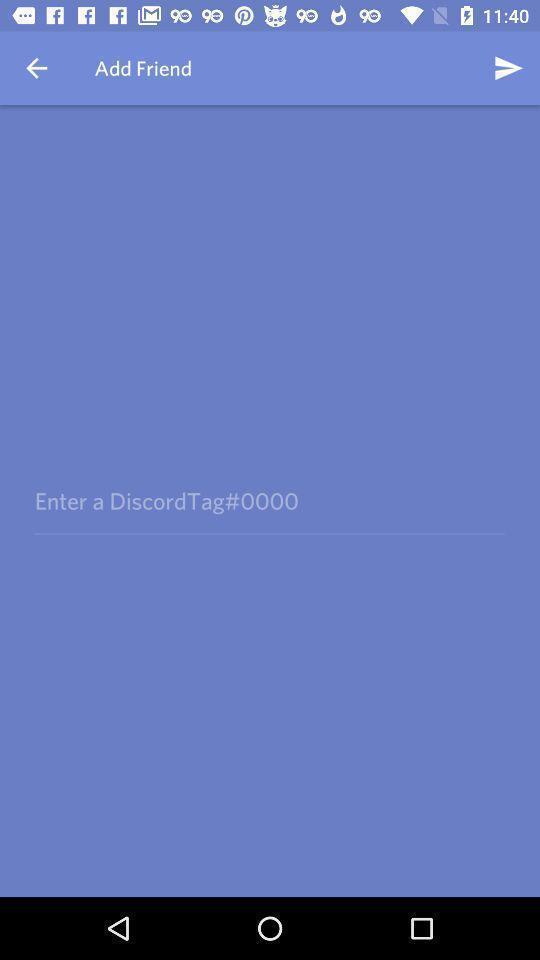Summarize the information in this screenshot. Page shows the enter option of discordtag to add friend. 